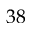Convert formula to latex. <formula><loc_0><loc_0><loc_500><loc_500>3 8</formula> 